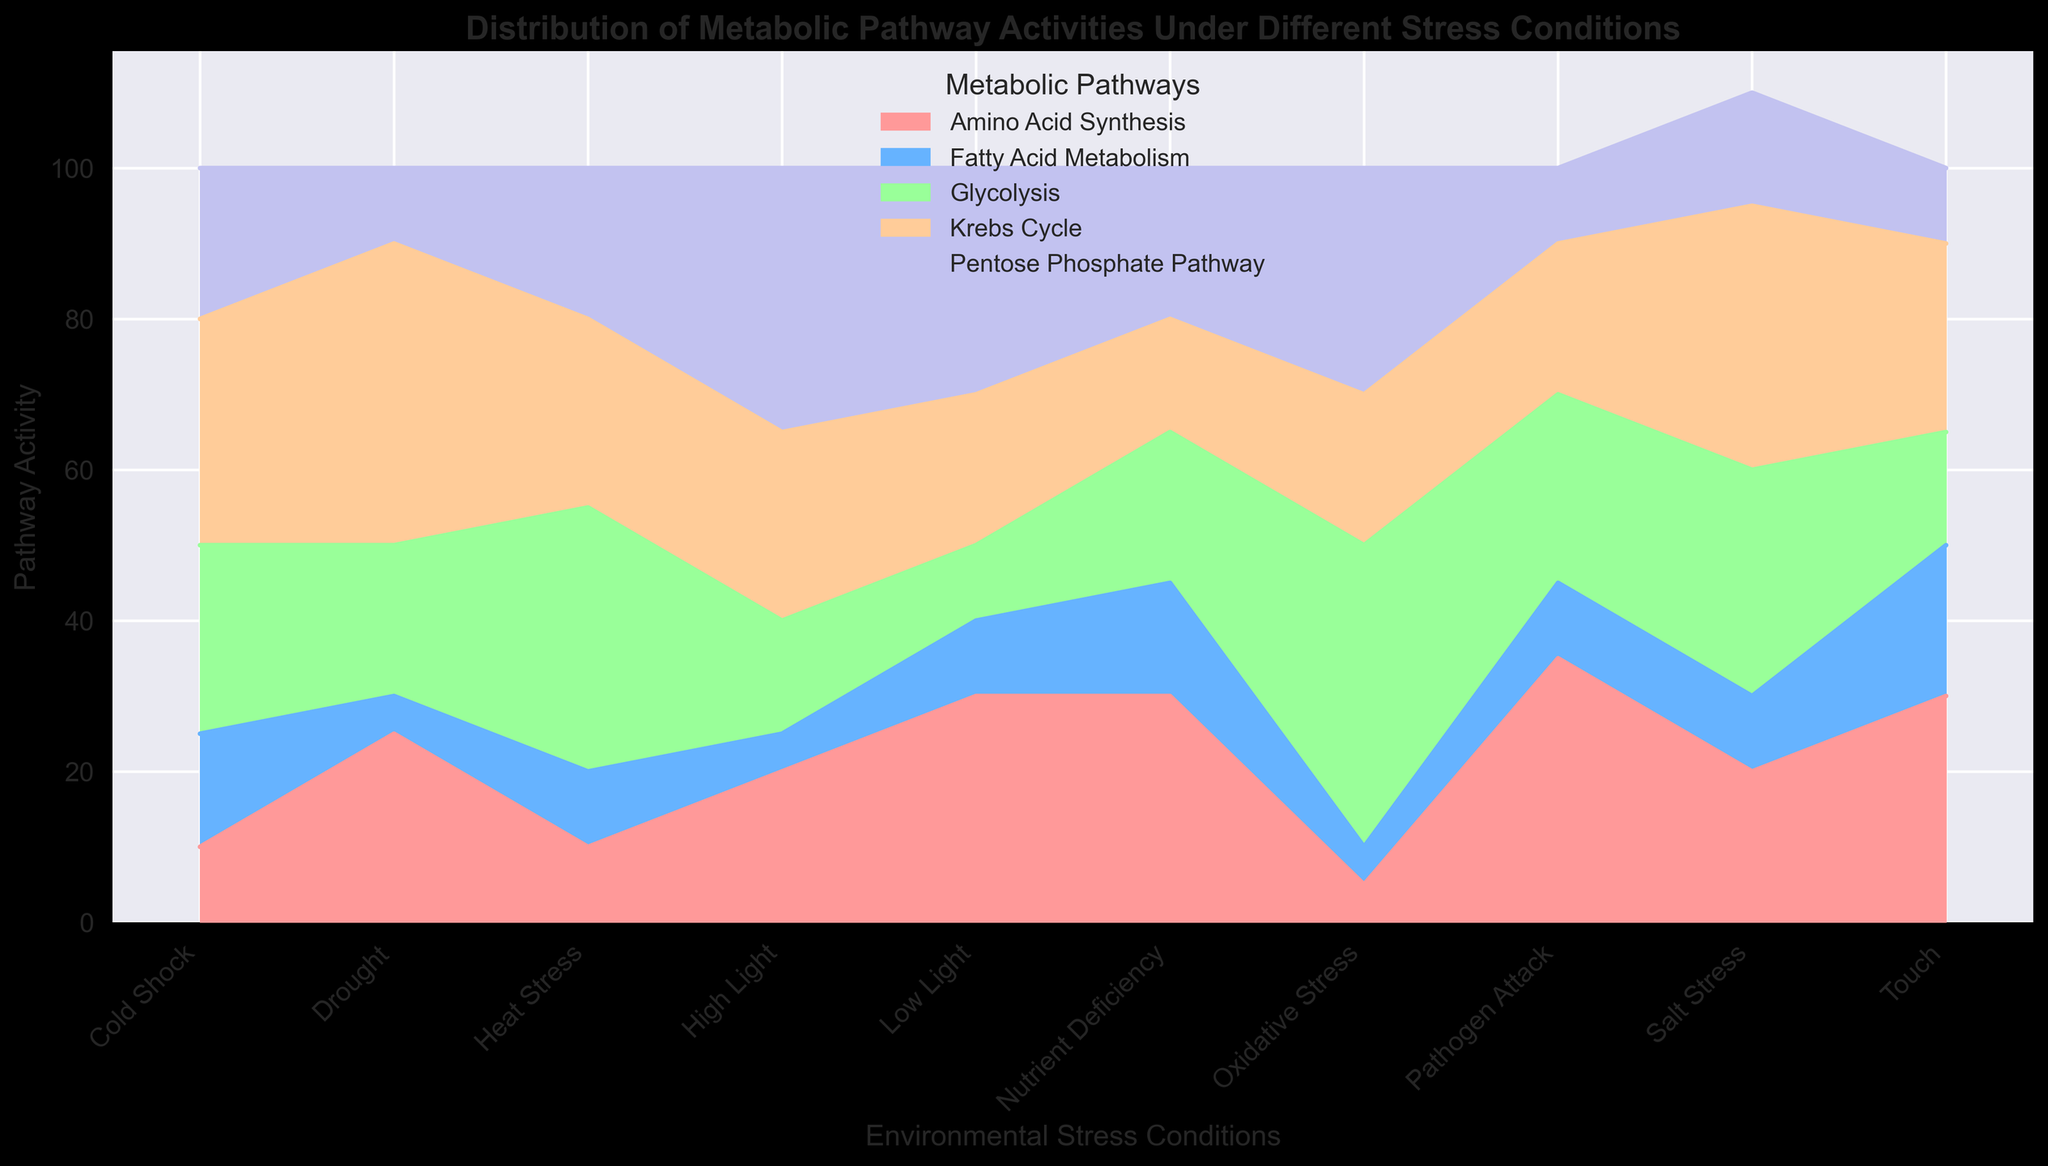What's the most active metabolic pathway under Oxidative Stress? Under Oxidative Stress, looking at the height of the colored areas representing different pathways, the "Pentose Phosphate Pathway" has the tallest height, indicating the highest activity level.
Answer: Pentose Phosphate Pathway Which environmental stress condition has the highest overall pathway activity? To determine this, observe which condition has the highest combined area of all pathways. By adding up the heights for all pathways under each condition, "Oxidative Stress" clearly shows the highest overall height.
Answer: Oxidative Stress Is the activity of Glycolysis higher under Heat Stress or Cold Shock? Compare the heights of the area representing Glycolysis for both conditions. Glycolysis is represented by a specific color, and under Heat Stress, this area is taller than under Cold Shock.
Answer: Heat Stress Which condition has the lowest activity for Fatty Acid Metabolism? Look for the condition where the area corresponding to Fatty Acid Metabolism is the smallest. Both "Drought" and "Oxidative Stress" show the lowest activity, but "Drought" has a slightly lower value.
Answer: Drought What is the combined activity of Krebs Cycle and Amino Acid Synthesis under Salt Stress? Extract the values for Krebs Cycle (35) and Amino Acid Synthesis (20) under Salt Stress and sum them up. 35 + 20 = 55
Answer: 55 How does the Pentose Phosphate Pathway activity under High Light compare to Low Light? Observe the heights of the areas representing the Pentose Phosphate Pathway under both conditions. High Light has a taller area for this pathway compared to Low Light.
Answer: Higher under High Light Which metabolic pathway's activity is relatively consistent across all conditions? Look for a pathway whose area remains relatively stable across all environmental stress conditions. "Fatty Acid Metabolism" shows relatively small and stable activity levels in all conditions compared to other pathways.
Answer: Fatty Acid Metabolism What's the average activity of the Krebs Cycle under Drought, Heat Stress, and Pathogen Attack conditions? Extract the Krebs Cycle activities for these conditions: Drought (40), Heat Stress (25), and Pathogen Attack (20). Sum them: 40 + 25 + 20 = 85. Divide by 3 to find the average: 85 / 3 ≈ 28.33
Answer: Approximately 28.33 In which condition does Glycolysis have the second highest activity, and what is the value? Identify the activities of Glycolysis under all conditions: highest is 40 (Oxidative Stress), second highest is 35 (Heat Stress).
Answer: Heat Stress, 35 